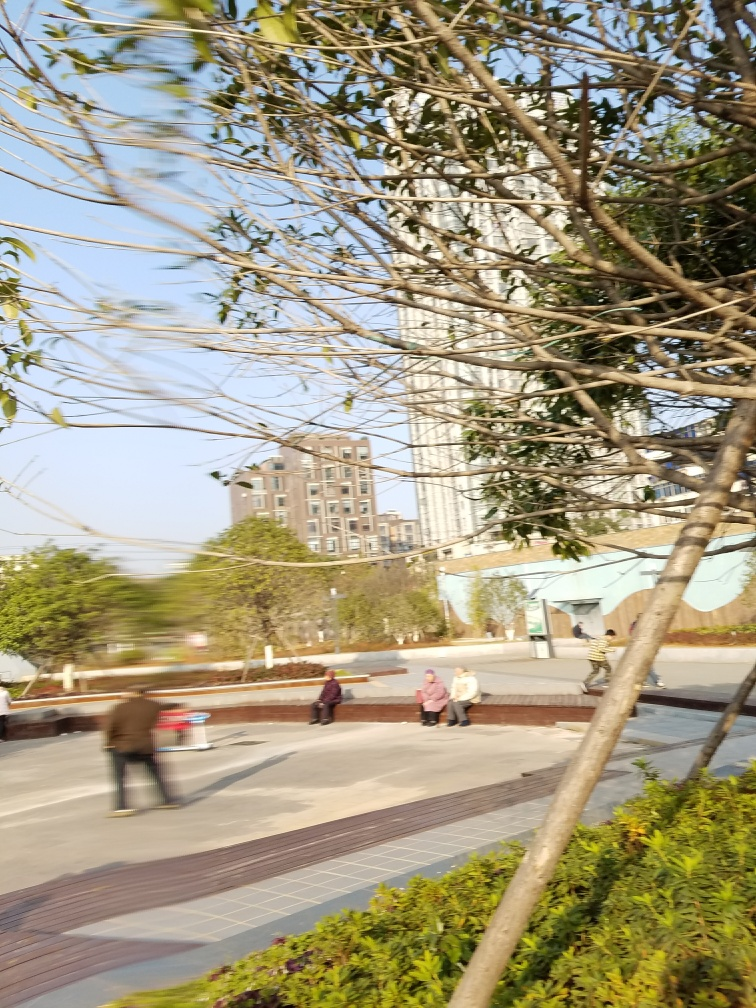What atmosphere does the picture convey? The picture conveys a peaceful and relaxed atmosphere. The presence of people seated and engaging in casual conversation, the clear sky, and the lush greenery all contribute to a sense of tranquility and respite from the surrounding urban sprawl.  What kinds of people can you see in the image? The image shows a diverse group of individuals. There are people sitting together on a park bench, likely enjoying a conversation, while another person appears to be walking briskly across the park, perhaps commuting or exercising. The age range looks varied, with perhaps adults and seniors present. 